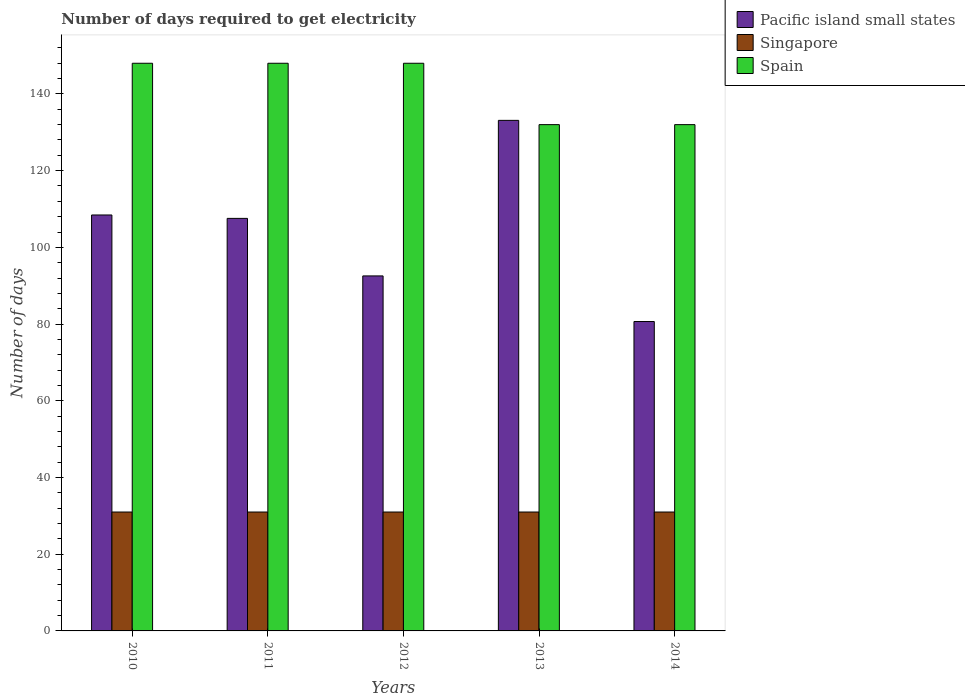How many bars are there on the 1st tick from the right?
Give a very brief answer. 3. What is the label of the 4th group of bars from the left?
Offer a very short reply. 2013. What is the number of days required to get electricity in in Spain in 2012?
Provide a short and direct response. 148. Across all years, what is the maximum number of days required to get electricity in in Singapore?
Give a very brief answer. 31. Across all years, what is the minimum number of days required to get electricity in in Pacific island small states?
Offer a very short reply. 80.67. In which year was the number of days required to get electricity in in Spain maximum?
Give a very brief answer. 2010. In which year was the number of days required to get electricity in in Spain minimum?
Make the answer very short. 2013. What is the total number of days required to get electricity in in Spain in the graph?
Your answer should be compact. 708. What is the difference between the number of days required to get electricity in in Singapore in 2011 and the number of days required to get electricity in in Spain in 2013?
Provide a short and direct response. -101. What is the average number of days required to get electricity in in Singapore per year?
Your response must be concise. 31. In the year 2014, what is the difference between the number of days required to get electricity in in Singapore and number of days required to get electricity in in Pacific island small states?
Your answer should be very brief. -49.67. What is the ratio of the number of days required to get electricity in in Singapore in 2013 to that in 2014?
Your answer should be compact. 1. Is the number of days required to get electricity in in Singapore in 2010 less than that in 2012?
Your answer should be compact. No. What is the difference between the highest and the lowest number of days required to get electricity in in Singapore?
Offer a very short reply. 0. What does the 3rd bar from the left in 2014 represents?
Offer a terse response. Spain. What does the 3rd bar from the right in 2010 represents?
Your answer should be very brief. Pacific island small states. Is it the case that in every year, the sum of the number of days required to get electricity in in Pacific island small states and number of days required to get electricity in in Spain is greater than the number of days required to get electricity in in Singapore?
Make the answer very short. Yes. How many bars are there?
Your response must be concise. 15. Does the graph contain any zero values?
Provide a succinct answer. No. Does the graph contain grids?
Your response must be concise. No. How many legend labels are there?
Provide a short and direct response. 3. What is the title of the graph?
Make the answer very short. Number of days required to get electricity. Does "Antigua and Barbuda" appear as one of the legend labels in the graph?
Provide a short and direct response. No. What is the label or title of the X-axis?
Your answer should be very brief. Years. What is the label or title of the Y-axis?
Your answer should be very brief. Number of days. What is the Number of days in Pacific island small states in 2010?
Give a very brief answer. 108.44. What is the Number of days of Singapore in 2010?
Provide a succinct answer. 31. What is the Number of days of Spain in 2010?
Your answer should be compact. 148. What is the Number of days of Pacific island small states in 2011?
Keep it short and to the point. 107.56. What is the Number of days of Singapore in 2011?
Make the answer very short. 31. What is the Number of days in Spain in 2011?
Your response must be concise. 148. What is the Number of days in Pacific island small states in 2012?
Your answer should be very brief. 92.56. What is the Number of days in Singapore in 2012?
Give a very brief answer. 31. What is the Number of days of Spain in 2012?
Your answer should be compact. 148. What is the Number of days of Pacific island small states in 2013?
Keep it short and to the point. 133.11. What is the Number of days of Spain in 2013?
Your answer should be very brief. 132. What is the Number of days in Pacific island small states in 2014?
Your answer should be compact. 80.67. What is the Number of days of Spain in 2014?
Provide a short and direct response. 132. Across all years, what is the maximum Number of days of Pacific island small states?
Give a very brief answer. 133.11. Across all years, what is the maximum Number of days in Spain?
Provide a succinct answer. 148. Across all years, what is the minimum Number of days of Pacific island small states?
Provide a short and direct response. 80.67. Across all years, what is the minimum Number of days of Singapore?
Your response must be concise. 31. Across all years, what is the minimum Number of days in Spain?
Your answer should be very brief. 132. What is the total Number of days of Pacific island small states in the graph?
Provide a short and direct response. 522.33. What is the total Number of days in Singapore in the graph?
Provide a short and direct response. 155. What is the total Number of days in Spain in the graph?
Provide a succinct answer. 708. What is the difference between the Number of days in Singapore in 2010 and that in 2011?
Offer a terse response. 0. What is the difference between the Number of days of Pacific island small states in 2010 and that in 2012?
Your answer should be compact. 15.89. What is the difference between the Number of days of Pacific island small states in 2010 and that in 2013?
Ensure brevity in your answer.  -24.67. What is the difference between the Number of days of Singapore in 2010 and that in 2013?
Provide a succinct answer. 0. What is the difference between the Number of days of Pacific island small states in 2010 and that in 2014?
Your answer should be compact. 27.78. What is the difference between the Number of days in Singapore in 2010 and that in 2014?
Your response must be concise. 0. What is the difference between the Number of days of Spain in 2010 and that in 2014?
Your answer should be compact. 16. What is the difference between the Number of days in Pacific island small states in 2011 and that in 2013?
Your answer should be compact. -25.56. What is the difference between the Number of days of Singapore in 2011 and that in 2013?
Your answer should be very brief. 0. What is the difference between the Number of days in Pacific island small states in 2011 and that in 2014?
Offer a very short reply. 26.89. What is the difference between the Number of days of Singapore in 2011 and that in 2014?
Ensure brevity in your answer.  0. What is the difference between the Number of days of Pacific island small states in 2012 and that in 2013?
Provide a succinct answer. -40.56. What is the difference between the Number of days in Pacific island small states in 2012 and that in 2014?
Your response must be concise. 11.89. What is the difference between the Number of days in Spain in 2012 and that in 2014?
Your response must be concise. 16. What is the difference between the Number of days in Pacific island small states in 2013 and that in 2014?
Your response must be concise. 52.44. What is the difference between the Number of days of Pacific island small states in 2010 and the Number of days of Singapore in 2011?
Offer a very short reply. 77.44. What is the difference between the Number of days in Pacific island small states in 2010 and the Number of days in Spain in 2011?
Keep it short and to the point. -39.56. What is the difference between the Number of days of Singapore in 2010 and the Number of days of Spain in 2011?
Give a very brief answer. -117. What is the difference between the Number of days of Pacific island small states in 2010 and the Number of days of Singapore in 2012?
Offer a terse response. 77.44. What is the difference between the Number of days of Pacific island small states in 2010 and the Number of days of Spain in 2012?
Provide a short and direct response. -39.56. What is the difference between the Number of days of Singapore in 2010 and the Number of days of Spain in 2012?
Provide a succinct answer. -117. What is the difference between the Number of days in Pacific island small states in 2010 and the Number of days in Singapore in 2013?
Give a very brief answer. 77.44. What is the difference between the Number of days of Pacific island small states in 2010 and the Number of days of Spain in 2013?
Give a very brief answer. -23.56. What is the difference between the Number of days of Singapore in 2010 and the Number of days of Spain in 2013?
Give a very brief answer. -101. What is the difference between the Number of days of Pacific island small states in 2010 and the Number of days of Singapore in 2014?
Make the answer very short. 77.44. What is the difference between the Number of days in Pacific island small states in 2010 and the Number of days in Spain in 2014?
Make the answer very short. -23.56. What is the difference between the Number of days in Singapore in 2010 and the Number of days in Spain in 2014?
Provide a succinct answer. -101. What is the difference between the Number of days in Pacific island small states in 2011 and the Number of days in Singapore in 2012?
Your answer should be very brief. 76.56. What is the difference between the Number of days in Pacific island small states in 2011 and the Number of days in Spain in 2012?
Provide a short and direct response. -40.44. What is the difference between the Number of days in Singapore in 2011 and the Number of days in Spain in 2012?
Provide a short and direct response. -117. What is the difference between the Number of days in Pacific island small states in 2011 and the Number of days in Singapore in 2013?
Offer a terse response. 76.56. What is the difference between the Number of days in Pacific island small states in 2011 and the Number of days in Spain in 2013?
Your answer should be very brief. -24.44. What is the difference between the Number of days of Singapore in 2011 and the Number of days of Spain in 2013?
Your response must be concise. -101. What is the difference between the Number of days in Pacific island small states in 2011 and the Number of days in Singapore in 2014?
Give a very brief answer. 76.56. What is the difference between the Number of days in Pacific island small states in 2011 and the Number of days in Spain in 2014?
Keep it short and to the point. -24.44. What is the difference between the Number of days of Singapore in 2011 and the Number of days of Spain in 2014?
Your response must be concise. -101. What is the difference between the Number of days in Pacific island small states in 2012 and the Number of days in Singapore in 2013?
Your answer should be compact. 61.56. What is the difference between the Number of days in Pacific island small states in 2012 and the Number of days in Spain in 2013?
Your response must be concise. -39.44. What is the difference between the Number of days in Singapore in 2012 and the Number of days in Spain in 2013?
Offer a very short reply. -101. What is the difference between the Number of days in Pacific island small states in 2012 and the Number of days in Singapore in 2014?
Provide a short and direct response. 61.56. What is the difference between the Number of days in Pacific island small states in 2012 and the Number of days in Spain in 2014?
Your answer should be compact. -39.44. What is the difference between the Number of days in Singapore in 2012 and the Number of days in Spain in 2014?
Make the answer very short. -101. What is the difference between the Number of days of Pacific island small states in 2013 and the Number of days of Singapore in 2014?
Give a very brief answer. 102.11. What is the difference between the Number of days in Singapore in 2013 and the Number of days in Spain in 2014?
Offer a very short reply. -101. What is the average Number of days of Pacific island small states per year?
Give a very brief answer. 104.47. What is the average Number of days in Singapore per year?
Give a very brief answer. 31. What is the average Number of days of Spain per year?
Provide a succinct answer. 141.6. In the year 2010, what is the difference between the Number of days in Pacific island small states and Number of days in Singapore?
Give a very brief answer. 77.44. In the year 2010, what is the difference between the Number of days of Pacific island small states and Number of days of Spain?
Your response must be concise. -39.56. In the year 2010, what is the difference between the Number of days of Singapore and Number of days of Spain?
Make the answer very short. -117. In the year 2011, what is the difference between the Number of days in Pacific island small states and Number of days in Singapore?
Keep it short and to the point. 76.56. In the year 2011, what is the difference between the Number of days of Pacific island small states and Number of days of Spain?
Your answer should be very brief. -40.44. In the year 2011, what is the difference between the Number of days in Singapore and Number of days in Spain?
Your answer should be compact. -117. In the year 2012, what is the difference between the Number of days of Pacific island small states and Number of days of Singapore?
Provide a succinct answer. 61.56. In the year 2012, what is the difference between the Number of days of Pacific island small states and Number of days of Spain?
Provide a succinct answer. -55.44. In the year 2012, what is the difference between the Number of days of Singapore and Number of days of Spain?
Provide a short and direct response. -117. In the year 2013, what is the difference between the Number of days of Pacific island small states and Number of days of Singapore?
Your answer should be very brief. 102.11. In the year 2013, what is the difference between the Number of days in Pacific island small states and Number of days in Spain?
Ensure brevity in your answer.  1.11. In the year 2013, what is the difference between the Number of days of Singapore and Number of days of Spain?
Make the answer very short. -101. In the year 2014, what is the difference between the Number of days in Pacific island small states and Number of days in Singapore?
Give a very brief answer. 49.67. In the year 2014, what is the difference between the Number of days of Pacific island small states and Number of days of Spain?
Offer a terse response. -51.33. In the year 2014, what is the difference between the Number of days in Singapore and Number of days in Spain?
Ensure brevity in your answer.  -101. What is the ratio of the Number of days of Pacific island small states in 2010 to that in 2011?
Offer a very short reply. 1.01. What is the ratio of the Number of days in Spain in 2010 to that in 2011?
Your answer should be compact. 1. What is the ratio of the Number of days of Pacific island small states in 2010 to that in 2012?
Offer a very short reply. 1.17. What is the ratio of the Number of days of Pacific island small states in 2010 to that in 2013?
Your answer should be very brief. 0.81. What is the ratio of the Number of days of Spain in 2010 to that in 2013?
Your response must be concise. 1.12. What is the ratio of the Number of days in Pacific island small states in 2010 to that in 2014?
Your response must be concise. 1.34. What is the ratio of the Number of days of Singapore in 2010 to that in 2014?
Your answer should be very brief. 1. What is the ratio of the Number of days in Spain in 2010 to that in 2014?
Your answer should be very brief. 1.12. What is the ratio of the Number of days of Pacific island small states in 2011 to that in 2012?
Keep it short and to the point. 1.16. What is the ratio of the Number of days of Singapore in 2011 to that in 2012?
Your answer should be very brief. 1. What is the ratio of the Number of days of Pacific island small states in 2011 to that in 2013?
Ensure brevity in your answer.  0.81. What is the ratio of the Number of days of Singapore in 2011 to that in 2013?
Provide a short and direct response. 1. What is the ratio of the Number of days in Spain in 2011 to that in 2013?
Your answer should be compact. 1.12. What is the ratio of the Number of days of Pacific island small states in 2011 to that in 2014?
Ensure brevity in your answer.  1.33. What is the ratio of the Number of days of Singapore in 2011 to that in 2014?
Give a very brief answer. 1. What is the ratio of the Number of days of Spain in 2011 to that in 2014?
Make the answer very short. 1.12. What is the ratio of the Number of days in Pacific island small states in 2012 to that in 2013?
Provide a short and direct response. 0.7. What is the ratio of the Number of days in Singapore in 2012 to that in 2013?
Give a very brief answer. 1. What is the ratio of the Number of days in Spain in 2012 to that in 2013?
Provide a succinct answer. 1.12. What is the ratio of the Number of days in Pacific island small states in 2012 to that in 2014?
Make the answer very short. 1.15. What is the ratio of the Number of days in Singapore in 2012 to that in 2014?
Provide a short and direct response. 1. What is the ratio of the Number of days of Spain in 2012 to that in 2014?
Keep it short and to the point. 1.12. What is the ratio of the Number of days in Pacific island small states in 2013 to that in 2014?
Ensure brevity in your answer.  1.65. What is the difference between the highest and the second highest Number of days in Pacific island small states?
Offer a terse response. 24.67. What is the difference between the highest and the second highest Number of days in Spain?
Your response must be concise. 0. What is the difference between the highest and the lowest Number of days in Pacific island small states?
Your answer should be compact. 52.44. 